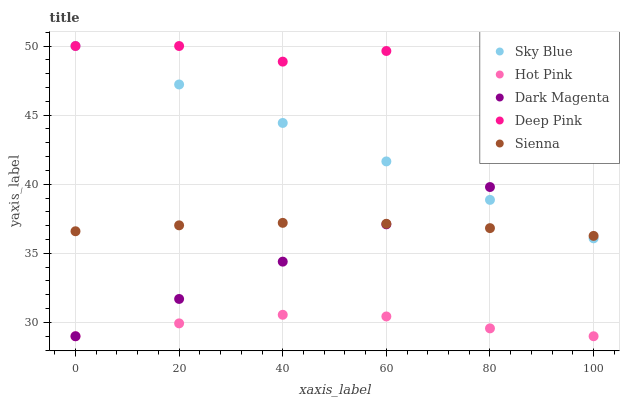Does Hot Pink have the minimum area under the curve?
Answer yes or no. Yes. Does Deep Pink have the maximum area under the curve?
Answer yes or no. Yes. Does Sky Blue have the minimum area under the curve?
Answer yes or no. No. Does Sky Blue have the maximum area under the curve?
Answer yes or no. No. Is Sky Blue the smoothest?
Answer yes or no. Yes. Is Deep Pink the roughest?
Answer yes or no. Yes. Is Hot Pink the smoothest?
Answer yes or no. No. Is Hot Pink the roughest?
Answer yes or no. No. Does Hot Pink have the lowest value?
Answer yes or no. Yes. Does Sky Blue have the lowest value?
Answer yes or no. No. Does Deep Pink have the highest value?
Answer yes or no. Yes. Does Hot Pink have the highest value?
Answer yes or no. No. Is Dark Magenta less than Deep Pink?
Answer yes or no. Yes. Is Sky Blue greater than Hot Pink?
Answer yes or no. Yes. Does Dark Magenta intersect Hot Pink?
Answer yes or no. Yes. Is Dark Magenta less than Hot Pink?
Answer yes or no. No. Is Dark Magenta greater than Hot Pink?
Answer yes or no. No. Does Dark Magenta intersect Deep Pink?
Answer yes or no. No. 